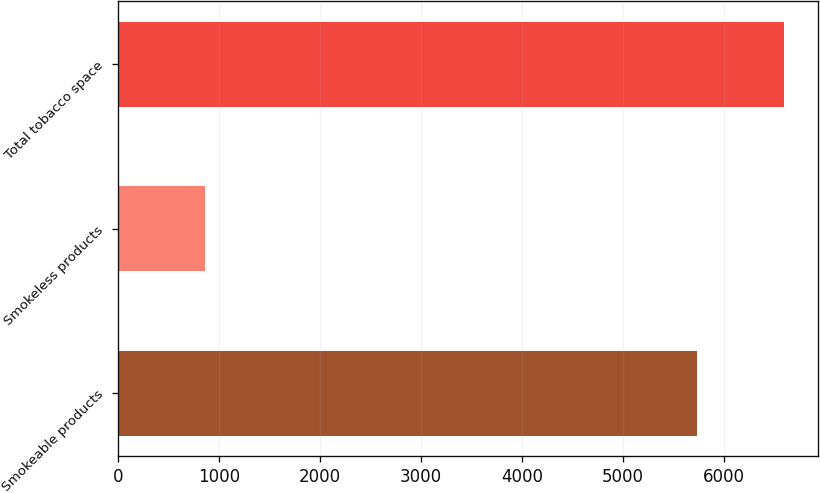<chart> <loc_0><loc_0><loc_500><loc_500><bar_chart><fcel>Smokeable products<fcel>Smokeless products<fcel>Total tobacco space<nl><fcel>5737<fcel>859<fcel>6596<nl></chart> 